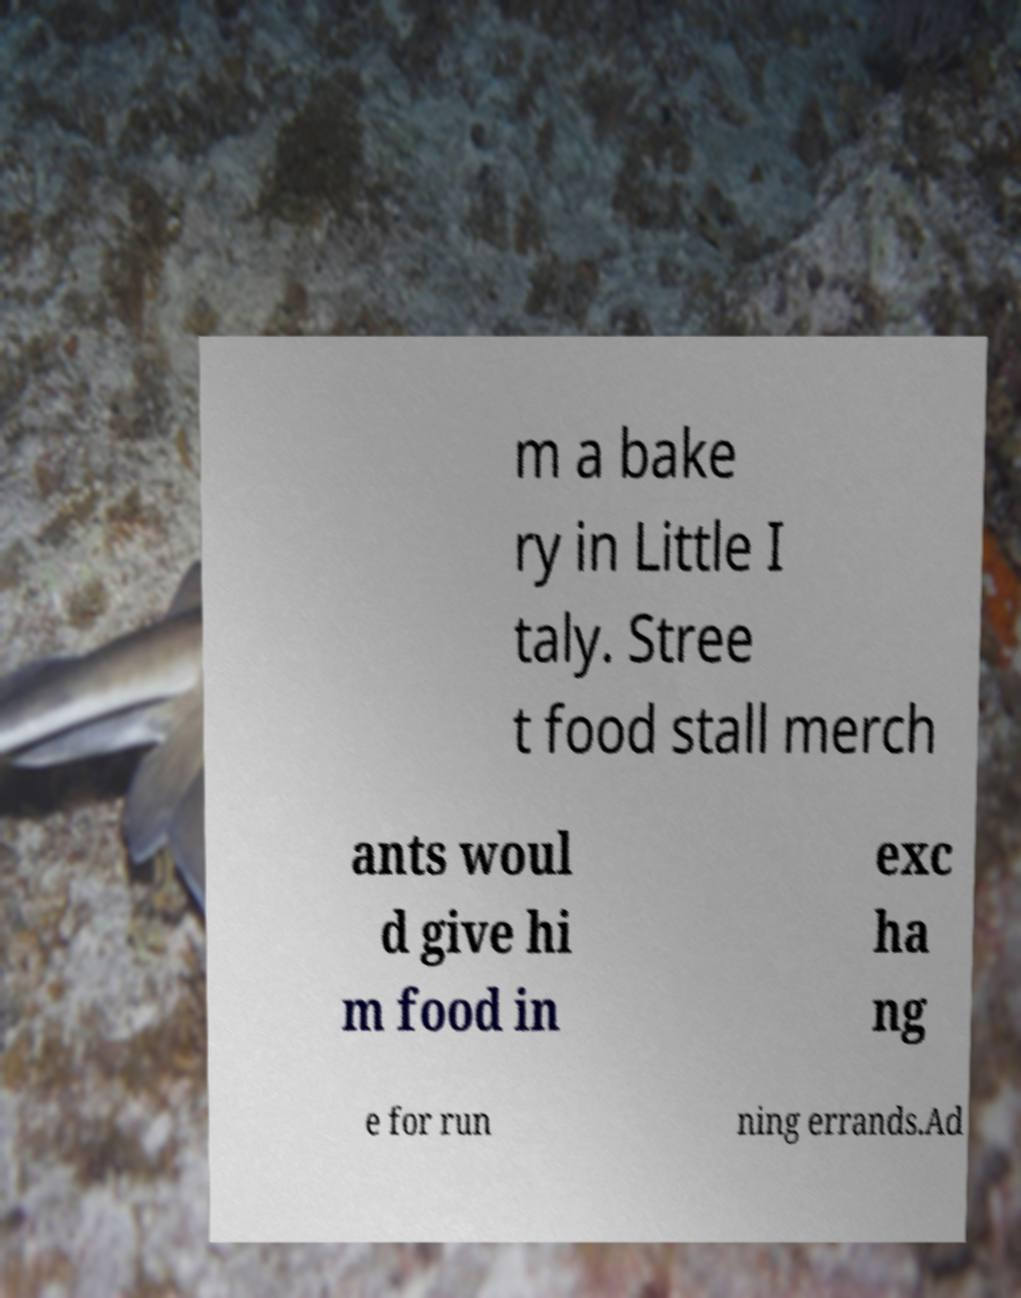Please read and relay the text visible in this image. What does it say? m a bake ry in Little I taly. Stree t food stall merch ants woul d give hi m food in exc ha ng e for run ning errands.Ad 